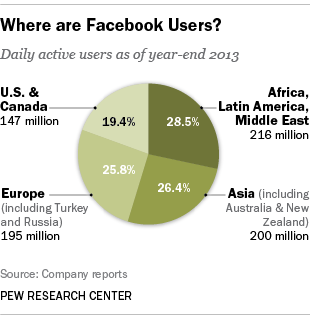Point out several critical features in this image. The pie graph shows that there are four distinct shades of green. The pie graph is divided into four parts. 